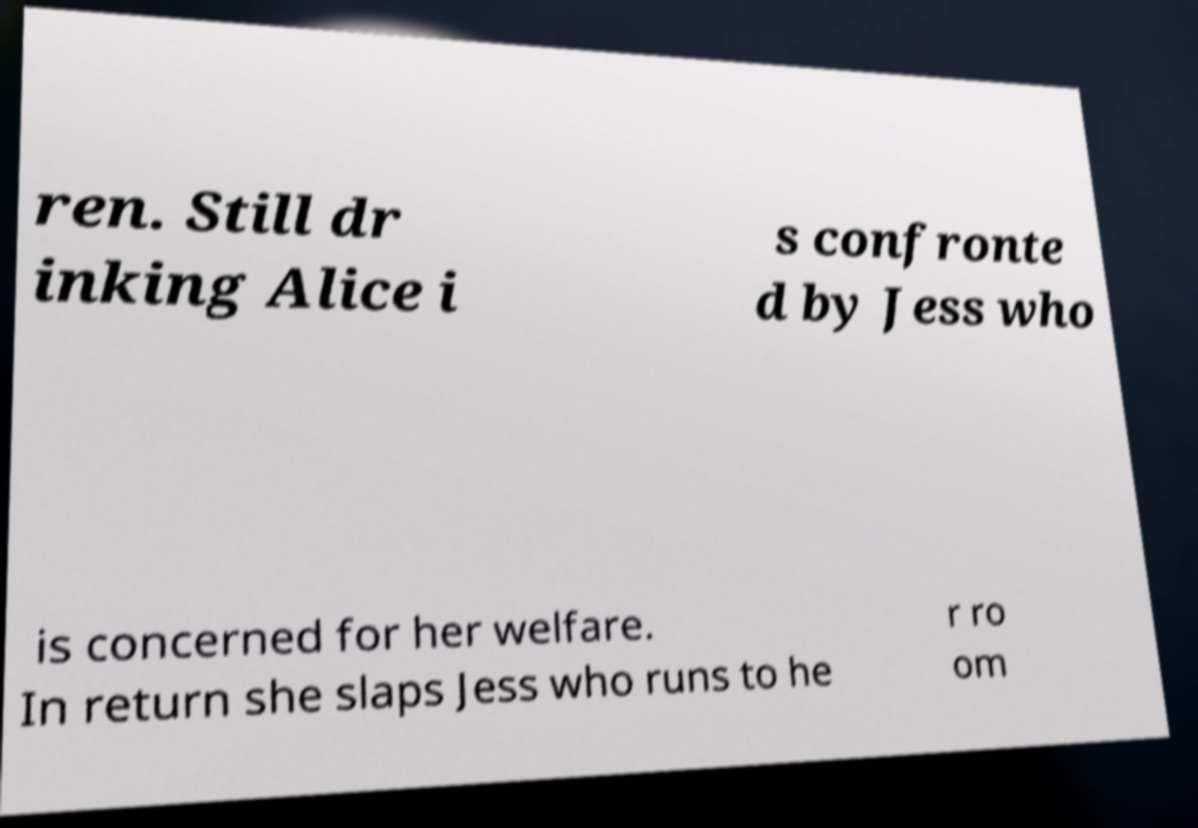Could you extract and type out the text from this image? ren. Still dr inking Alice i s confronte d by Jess who is concerned for her welfare. In return she slaps Jess who runs to he r ro om 